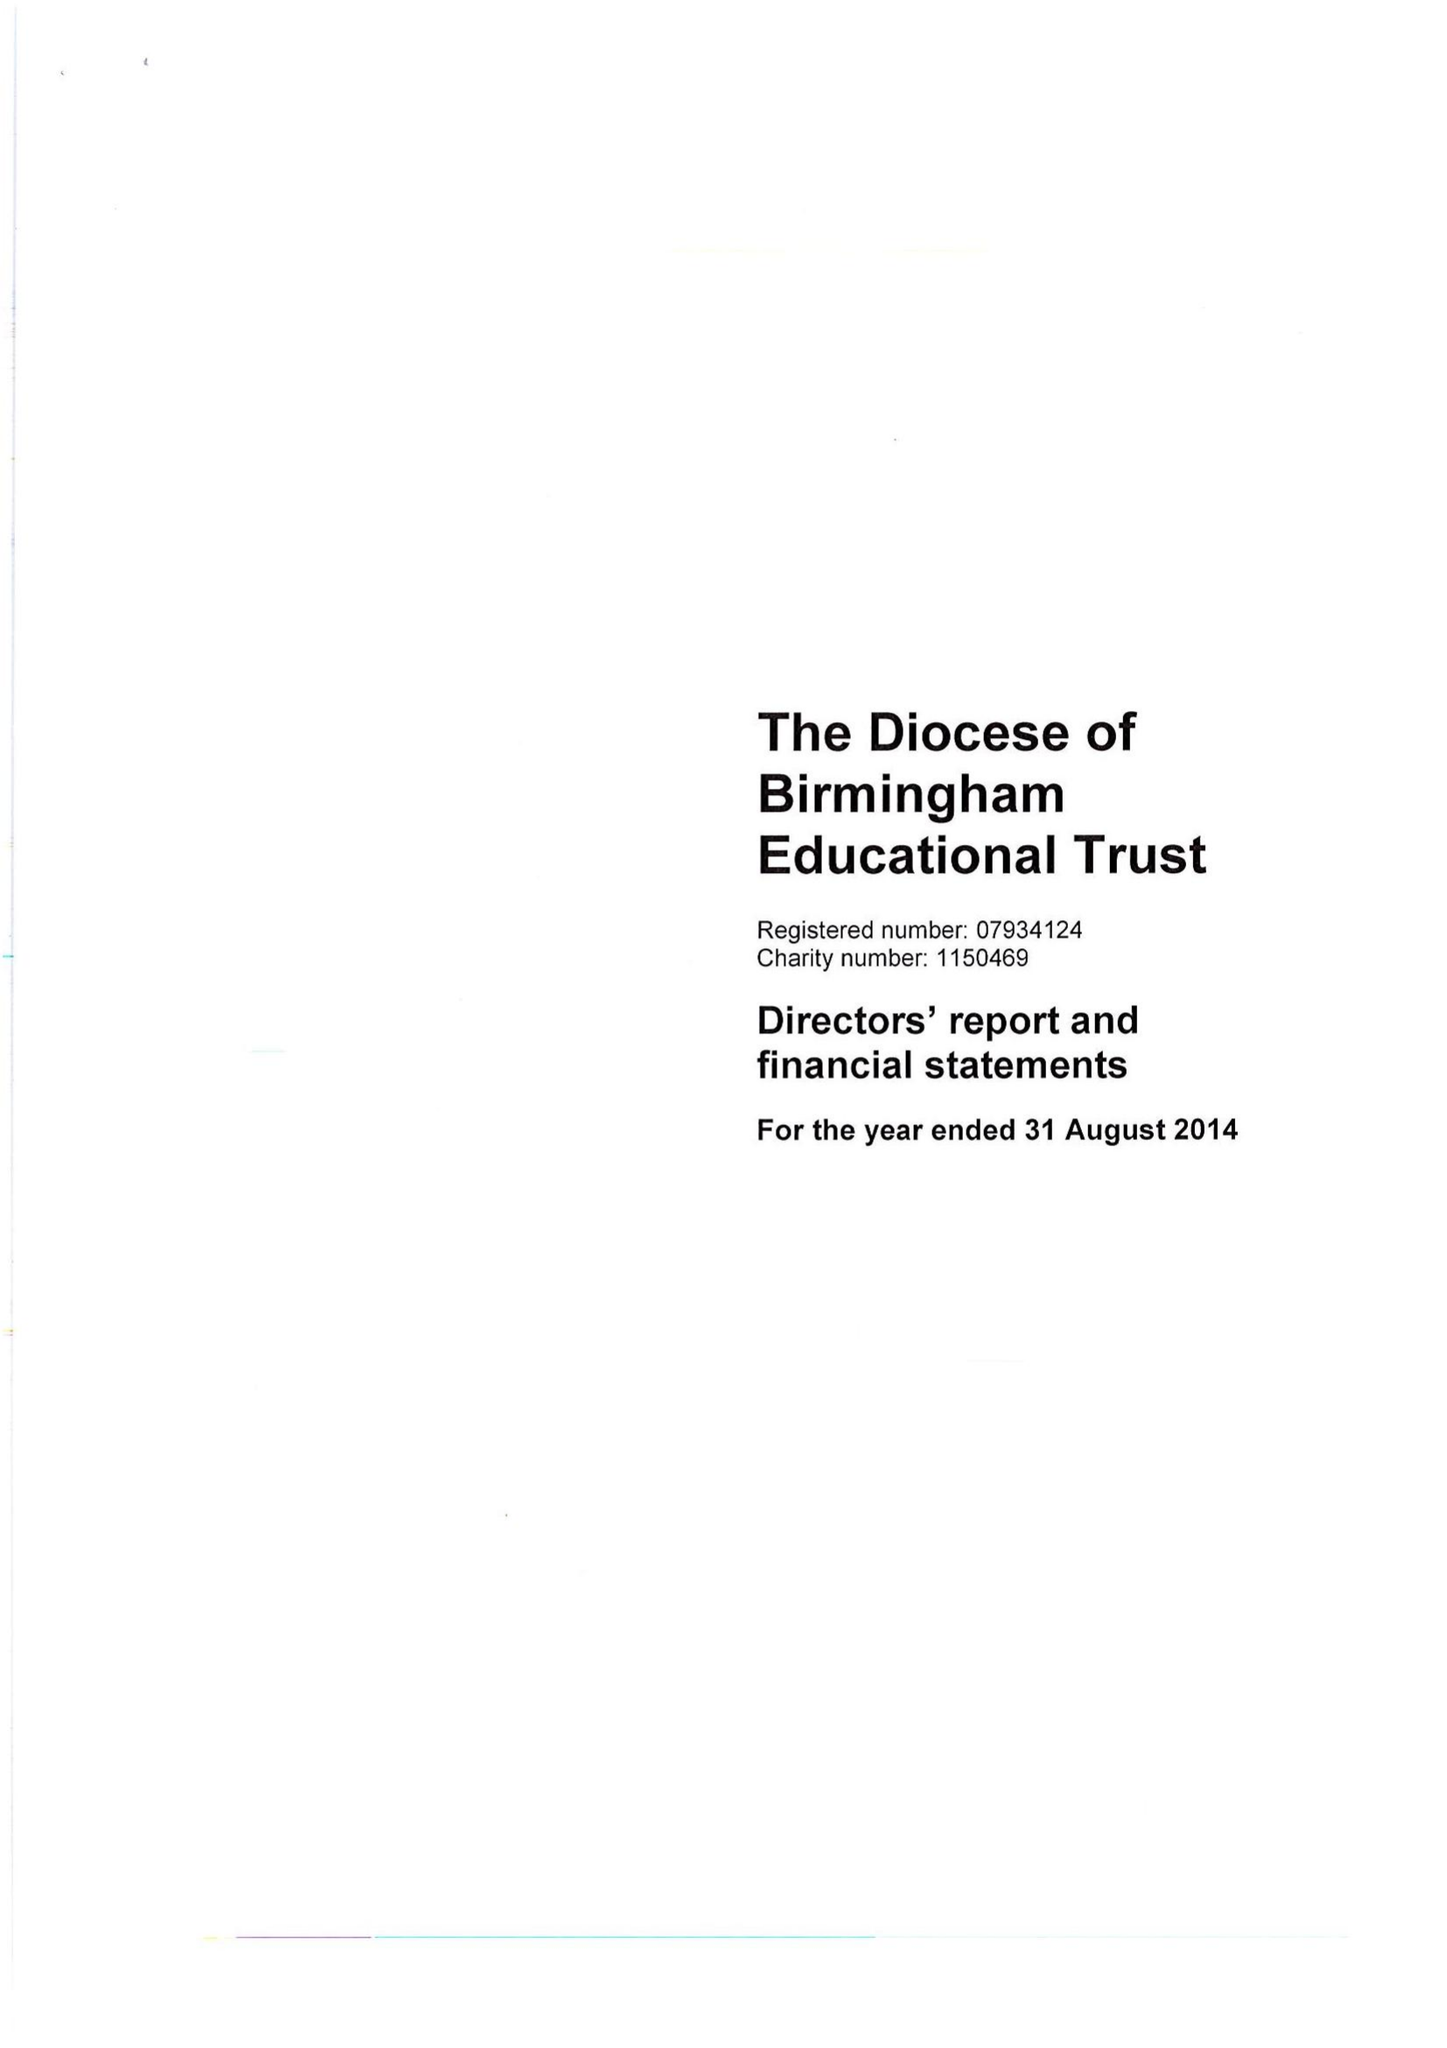What is the value for the address__street_line?
Answer the question using a single word or phrase. 1 COLMORE ROW 